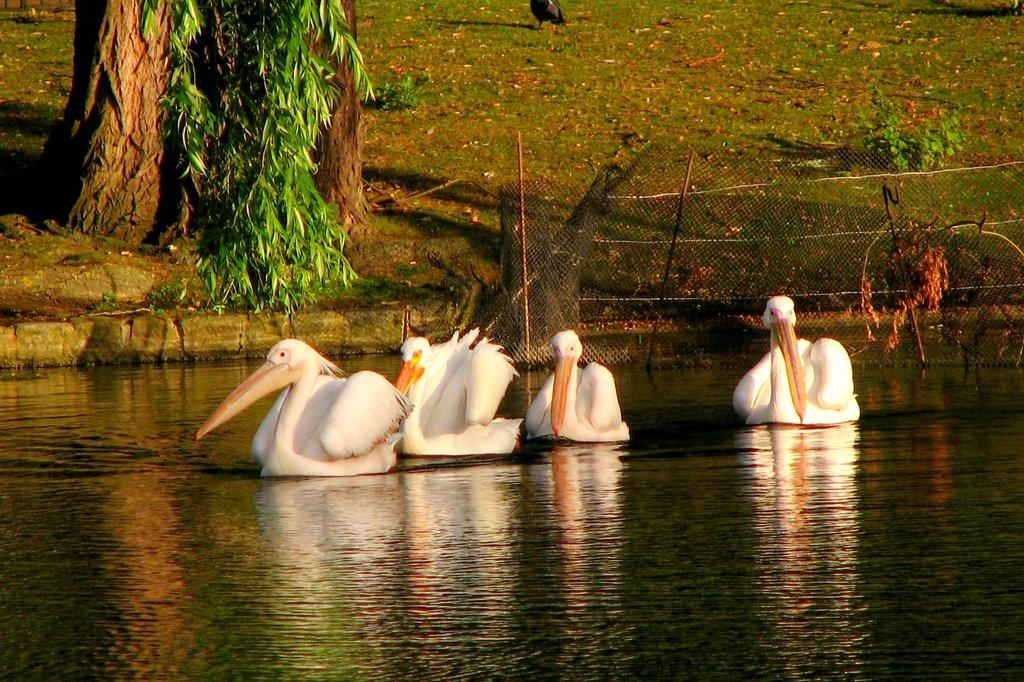What animals can be seen in the water in the image? There are ducks swimming in the water in the image. What type of fencing is present on the ground? There is an iron fencing on the ground. What type of vegetation covers the ground in the image? The ground is covered with grass. What other natural elements can be seen in the image? There are trees in the image. What type of business is being conducted in the bedroom in the image? There is no bedroom or business activity present in the image; it features ducks swimming in the water, iron fencing, grass-covered ground, and trees. 